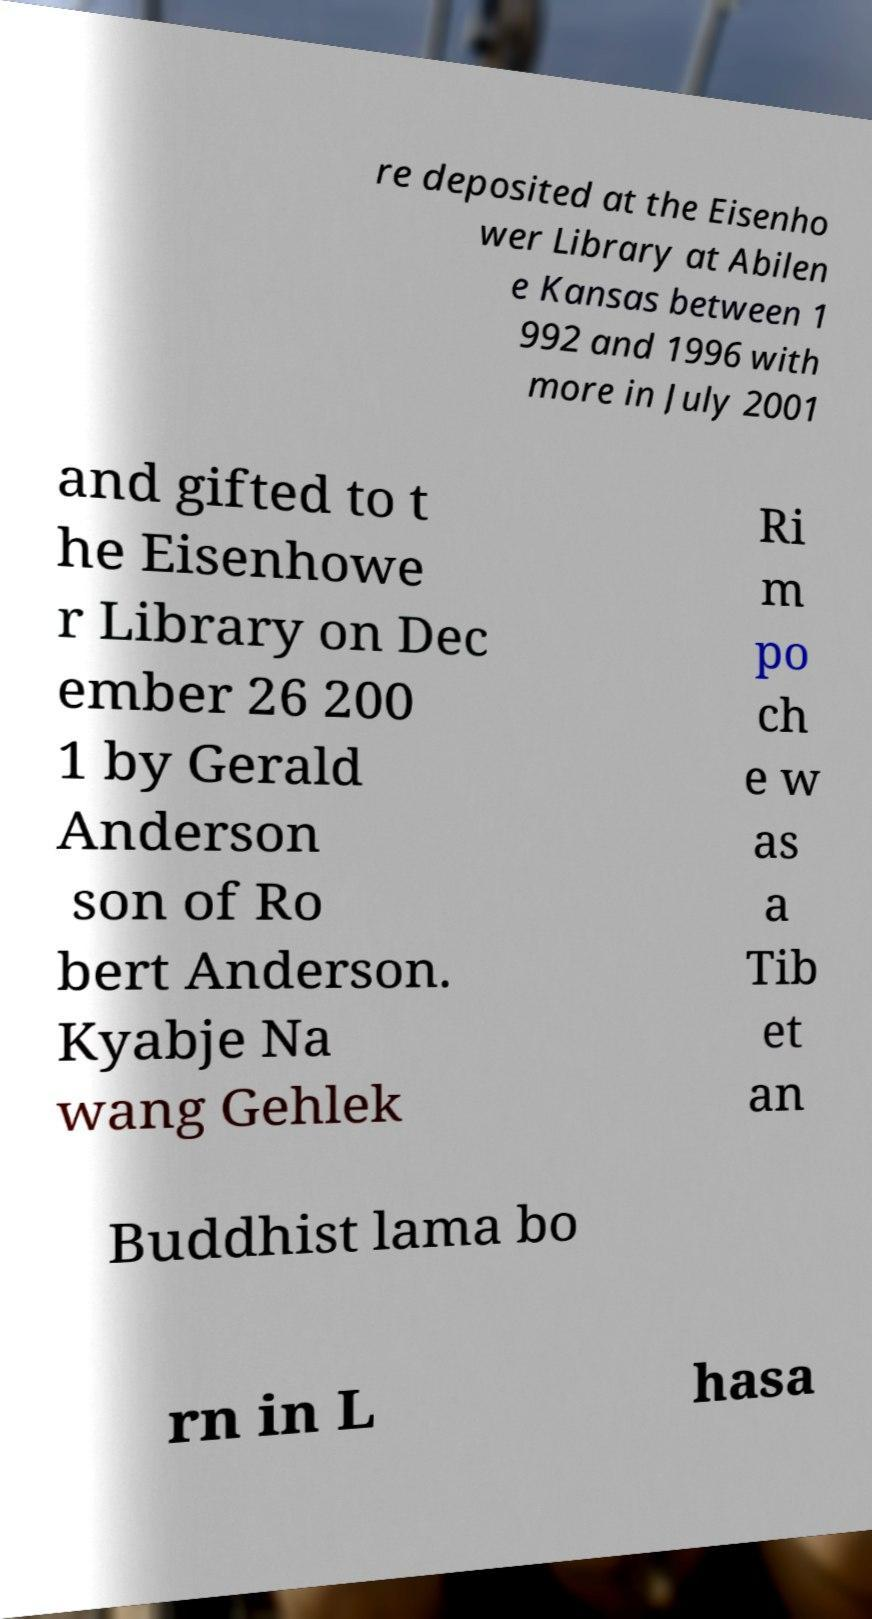Can you accurately transcribe the text from the provided image for me? re deposited at the Eisenho wer Library at Abilen e Kansas between 1 992 and 1996 with more in July 2001 and gifted to t he Eisenhowe r Library on Dec ember 26 200 1 by Gerald Anderson son of Ro bert Anderson. Kyabje Na wang Gehlek Ri m po ch e w as a Tib et an Buddhist lama bo rn in L hasa 